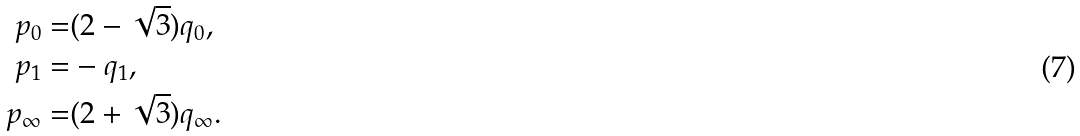Convert formula to latex. <formula><loc_0><loc_0><loc_500><loc_500>p _ { 0 } = & ( 2 - \sqrt { 3 } ) q _ { 0 } , \\ p _ { 1 } = & - q _ { 1 } , \\ p _ { \infty } = & ( 2 + \sqrt { 3 } ) q _ { \infty } .</formula> 